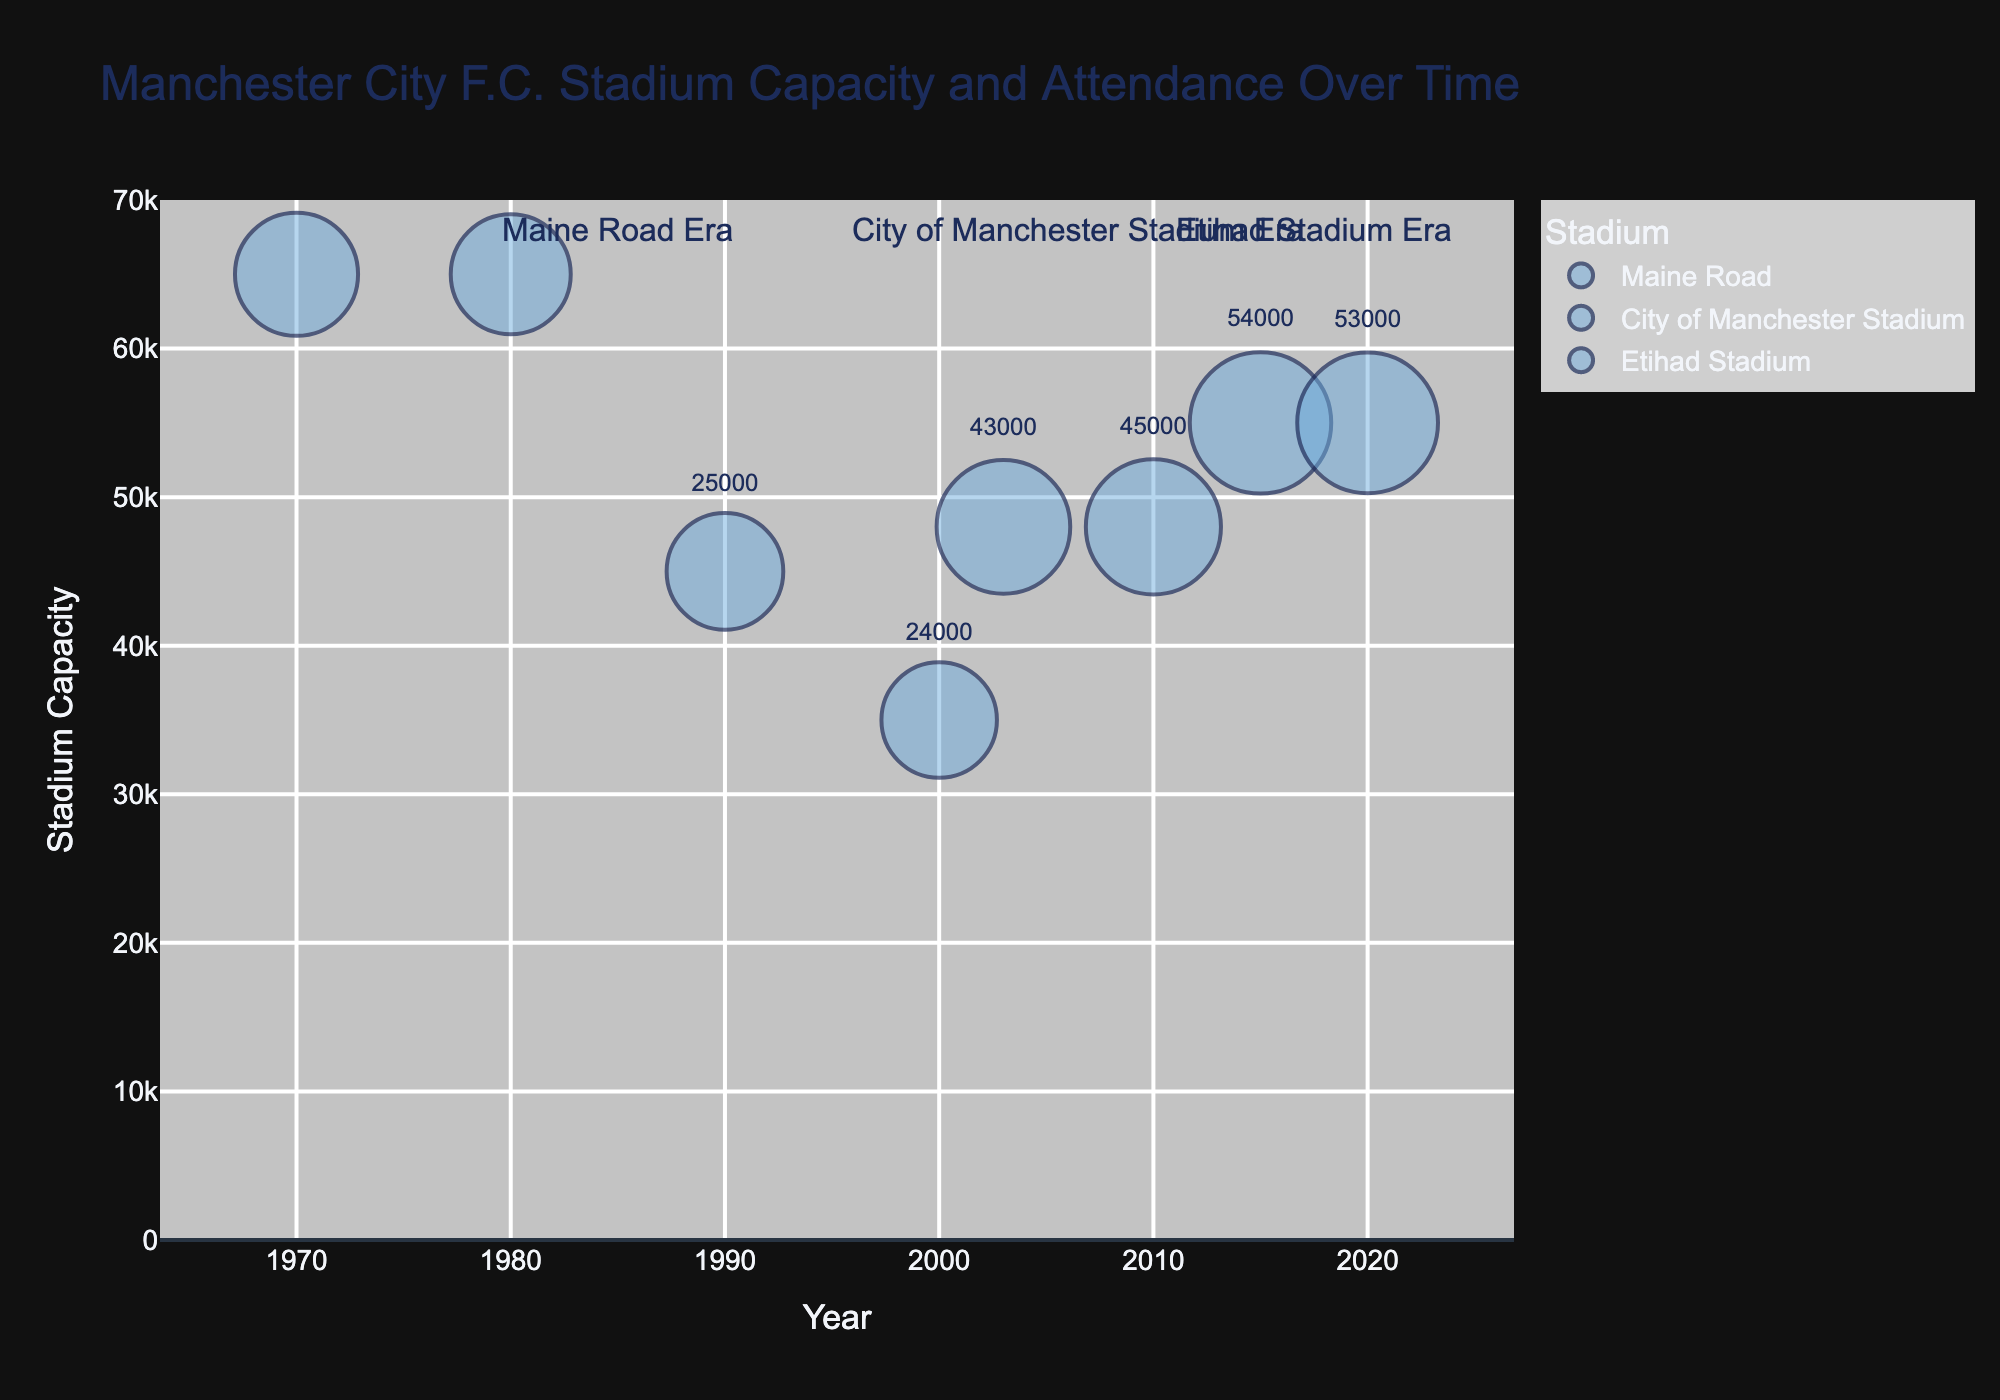What is the title of the chart? The title is prominently displayed at the top of the chart.
Answer: Manchester City F.C. Stadium Capacity and Attendance Over Time What does the size of each bubble represent? The bubble size is directly correlated with the average attendance figure, which is represented visually by the size of each bubble.
Answer: Average attendance How many stadiums are represented in the chart? Each stadium is represented by a different color for the bubbles.
Answer: Three (Maine Road, City of Manchester Stadium, Etihad Stadium) What is the capacity range of the stadiums used by Manchester City F.C. over the decades? The stadium capacities can be observed on the y-axis, ranging from the lowest to highest values.
Answer: 35,000 to 65,000 What was the approximate average attendance at Maine Road in 1970 compared to 1980? Look at the bubble size at 1970 and 1980 within the Maine Road section on the chart. The 1970 bubble (approx ~31,000) is slightly larger than the 1980 bubble (approx ~28,000).
Answer: 31,000 in 1970 and 28,000 in 1980 What trend can be observed in the average attendance from Maine Road in 2000 to the Etihad Stadium in 2020? Trace the transition across the years, focusing on the sizes of the bubbles: from Maine Road in 2000 (~24,000) to the City of Manchester Stadium (~43,000) and finally to Etihad Stadium (~53,000). This shows an increasing trend in attendance.
Answer: Increasing trend How does the average attendance in 2015 at the Etihad Stadium compare to the stadium capacity? The y-position of the bubble indicates the stadium capacity (~55,000) and the size of the bubble represents the average attendance (~54,000).
Answer: Nearly the same, 54,000 out of 55,000 Which stadium transition showed the greatest increase in average attendance? Compare the jumps in the sizes of bubbles between different transitions: Maine Road to City of Manchester Stadium (2000-2003) and City of Manchester Stadium to Etihad Stadium (2010-2015). The greatest increase is observed from Maine Road in 2000 (24,000) to City of Manchester Stadium in 2003 (43,000).
Answer: Maine Road to City of Manchester Stadium Is there a significant overlap in average attendance between any two different stadiums? Overlap can be checked by looking for similar-sized bubbles in different color sections. No two bubbles from different stadiums have the exact same size, e.g., the closest overlap is between City of Manchester Stadium (2010, ~45,000) and Etihad Stadium (2020, ~53,000).
Answer: No significant overlap 